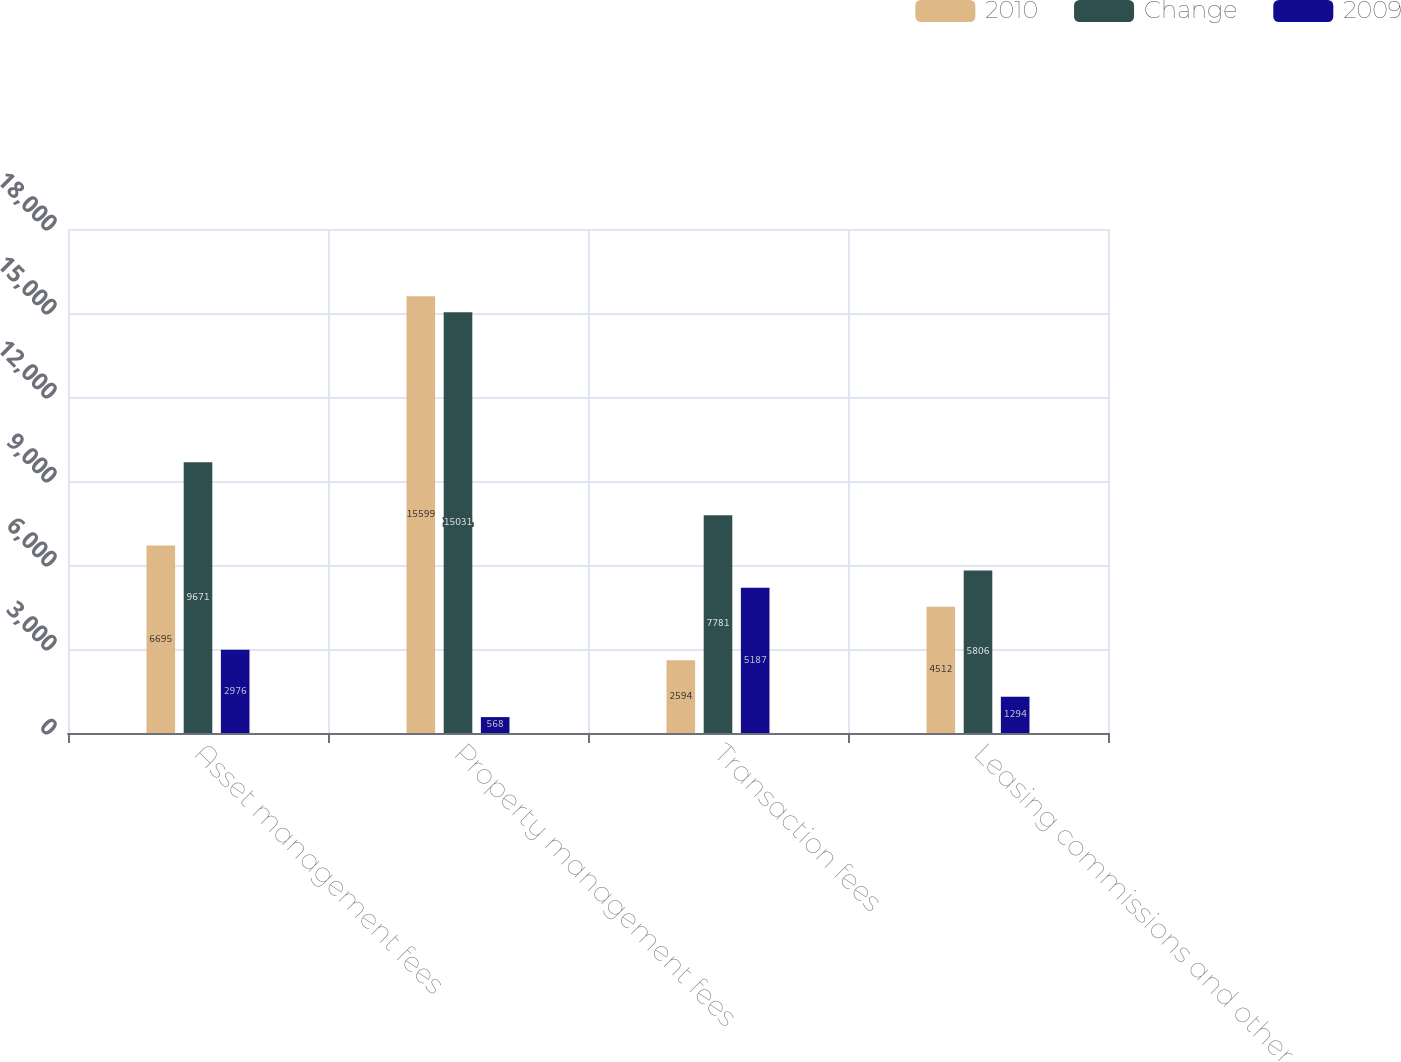Convert chart to OTSL. <chart><loc_0><loc_0><loc_500><loc_500><stacked_bar_chart><ecel><fcel>Asset management fees<fcel>Property management fees<fcel>Transaction fees<fcel>Leasing commissions and other<nl><fcel>2010<fcel>6695<fcel>15599<fcel>2594<fcel>4512<nl><fcel>Change<fcel>9671<fcel>15031<fcel>7781<fcel>5806<nl><fcel>2009<fcel>2976<fcel>568<fcel>5187<fcel>1294<nl></chart> 